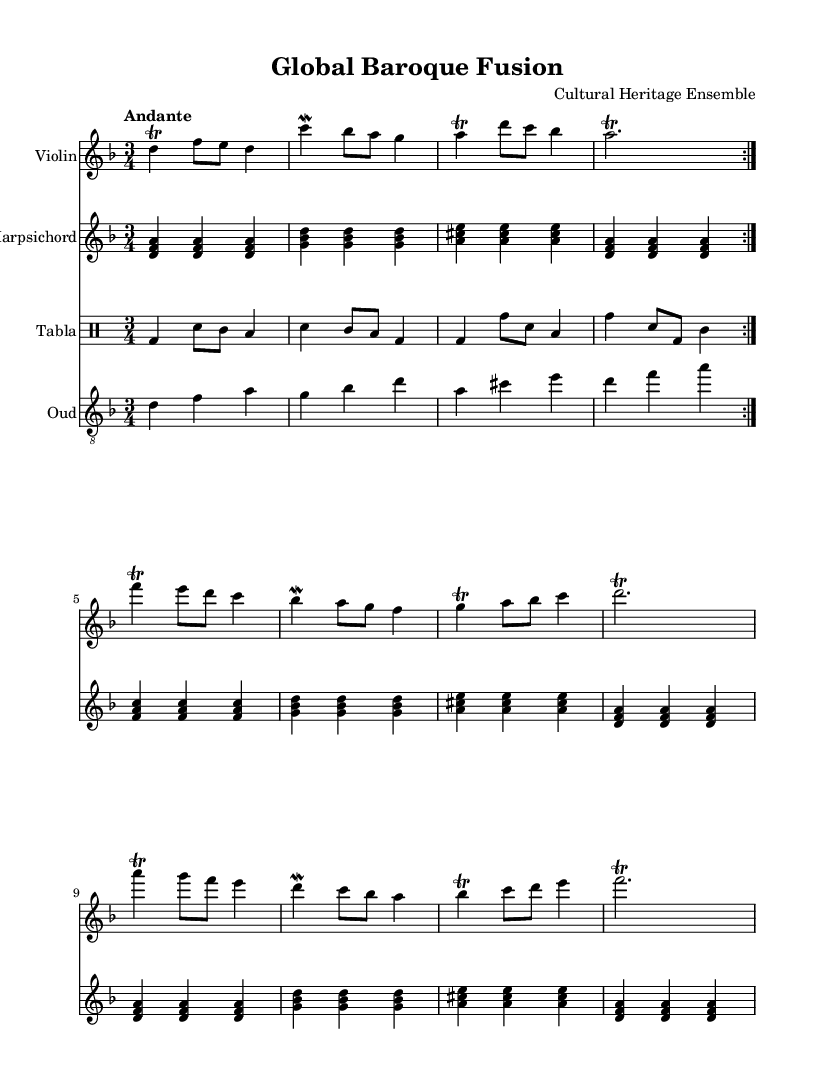What is the key signature of this music? The key signature is D minor, which contains one flat (B flat). This can be determined by looking at the key signature at the beginning of the staff.
Answer: D minor What is the time signature of this piece? The time signature is 3/4, indicated at the beginning of the score. This means there are three beats in each measure and the quarter note receives one beat.
Answer: 3/4 What is the tempo marking for this piece? The tempo marking is "Andante," which indicates a moderately slow tempo. This is usually found above the staff near the beginning of the score.
Answer: Andante How many times does the violin section repeat? The violin section repeats twice, as indicated by the "volta" markings in the music, which denote repeated sections.
Answer: 2 What type of traditional instrument is featured alongside the tabla? The featured traditional instrument is the oud, which is indicated in the score. It is often used in Middle Eastern music.
Answer: Oud What is the function of the tabla in this composition? The tabla serves as a rhythmic accompaniment throughout the piece, providing a unique percussive texture that complements the melodic instruments. This is understood from the presence of a drum staff dedicated to the tabla.
Answer: Rhythm How does the harpsichord contribute to the texture of the music? The harpsichord contributes by providing harmonic support through chords and arpeggios, which can be seen in the repeated chord structures it plays throughout the score.
Answer: Harmonic support 